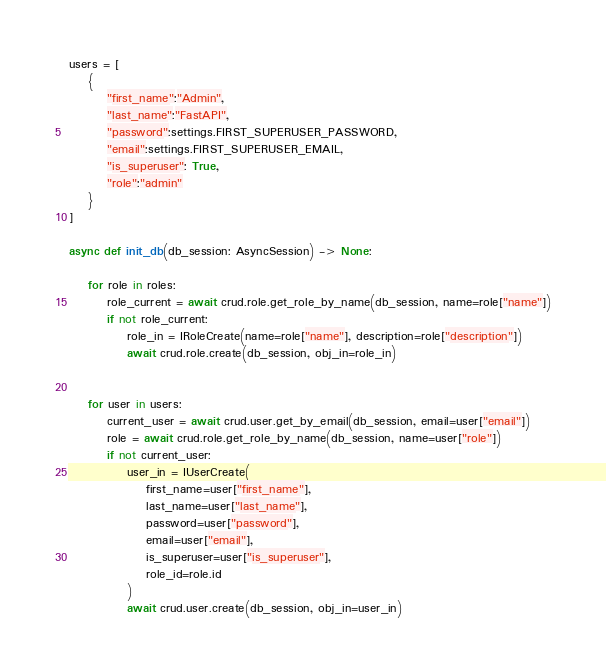<code> <loc_0><loc_0><loc_500><loc_500><_Python_>
users = [
    {
        "first_name":"Admin",
        "last_name":"FastAPI",
        "password":settings.FIRST_SUPERUSER_PASSWORD,
        "email":settings.FIRST_SUPERUSER_EMAIL,
        "is_superuser": True,
        "role":"admin"
    }         
]

async def init_db(db_session: AsyncSession) -> None:

    for role in roles:
        role_current = await crud.role.get_role_by_name(db_session, name=role["name"])
        if not role_current:
            role_in = IRoleCreate(name=role["name"], description=role["description"])
            await crud.role.create(db_session, obj_in=role_in)

    
    for user in users:
        current_user = await crud.user.get_by_email(db_session, email=user["email"])
        role = await crud.role.get_role_by_name(db_session, name=user["role"])
        if not current_user:
            user_in = IUserCreate(
                first_name=user["first_name"],
                last_name=user["last_name"],
                password=user["password"],
                email=user["email"],
                is_superuser=user["is_superuser"],
                role_id=role.id
            )
            await crud.user.create(db_session, obj_in=user_in)
</code> 